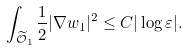Convert formula to latex. <formula><loc_0><loc_0><loc_500><loc_500>\int _ { \widetilde { \mathcal { O } } _ { 1 } } \frac { 1 } { 2 } | \nabla w _ { 1 } | ^ { 2 } \leq C | \log \varepsilon | .</formula> 